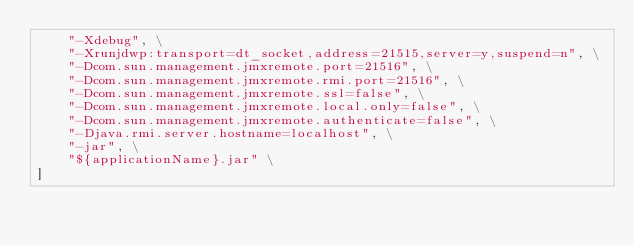Convert code to text. <code><loc_0><loc_0><loc_500><loc_500><_Dockerfile_>    "-Xdebug", \
    "-Xrunjdwp:transport=dt_socket,address=21515,server=y,suspend=n", \
    "-Dcom.sun.management.jmxremote.port=21516", \
    "-Dcom.sun.management.jmxremote.rmi.port=21516", \
    "-Dcom.sun.management.jmxremote.ssl=false", \
    "-Dcom.sun.management.jmxremote.local.only=false", \
    "-Dcom.sun.management.jmxremote.authenticate=false", \
    "-Djava.rmi.server.hostname=localhost", \
    "-jar", \
    "${applicationName}.jar" \
]
</code> 